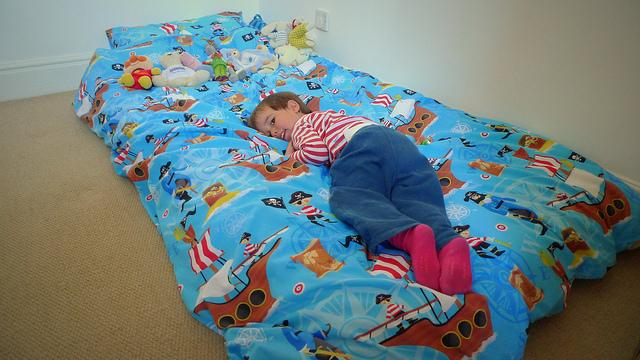The boy is wearing a shirt that looks like the shirt of a character in what series? Please explain your reasoning. where's waldo. A kid is wearing a red and white striped shirt. 